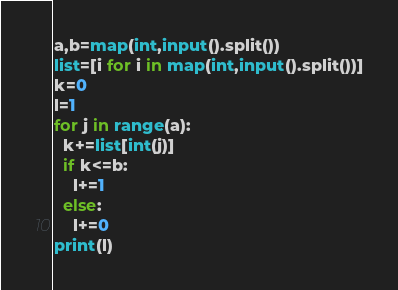<code> <loc_0><loc_0><loc_500><loc_500><_Python_>a,b=map(int,input().split())
list=[i for i in map(int,input().split())]
k=0
l=1
for j in range(a):
  k+=list[int(j)]
  if k<=b:
    l+=1
  else:
    l+=0
print(l)</code> 